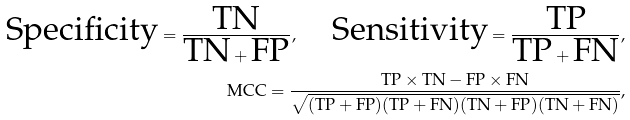<formula> <loc_0><loc_0><loc_500><loc_500>\text {Specificity} = \frac { \text {TN} } { \text {TN} + \text {FP} } , \quad \text {Sensitivity} = \frac { \text {TP} } { \text {TP} + \text {FN} } , \\ \text {MCC} = \frac { \text {TP} \times \text {TN} - \text {FP} \times \text {FN} } { \sqrt { ( \text {TP} + \text {FP} ) ( \text {TP} + \text {FN} ) ( \text {TN} + \text {FP} ) ( \text {TN} + \text {FN} ) } } ,</formula> 